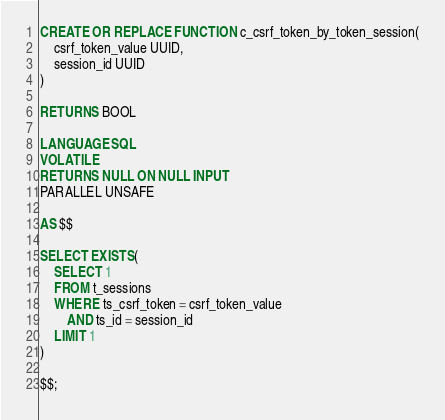Convert code to text. <code><loc_0><loc_0><loc_500><loc_500><_SQL_>
CREATE OR REPLACE FUNCTION c_csrf_token_by_token_session(
    csrf_token_value UUID,
    session_id UUID
)

RETURNS BOOL

LANGUAGE SQL
VOLATILE
RETURNS NULL ON NULL INPUT
PARALLEL UNSAFE

AS $$

SELECT EXISTS(
    SELECT 1
    FROM t_sessions
    WHERE ts_csrf_token = csrf_token_value
        AND ts_id = session_id
    LIMIT 1
)

$$;
</code> 